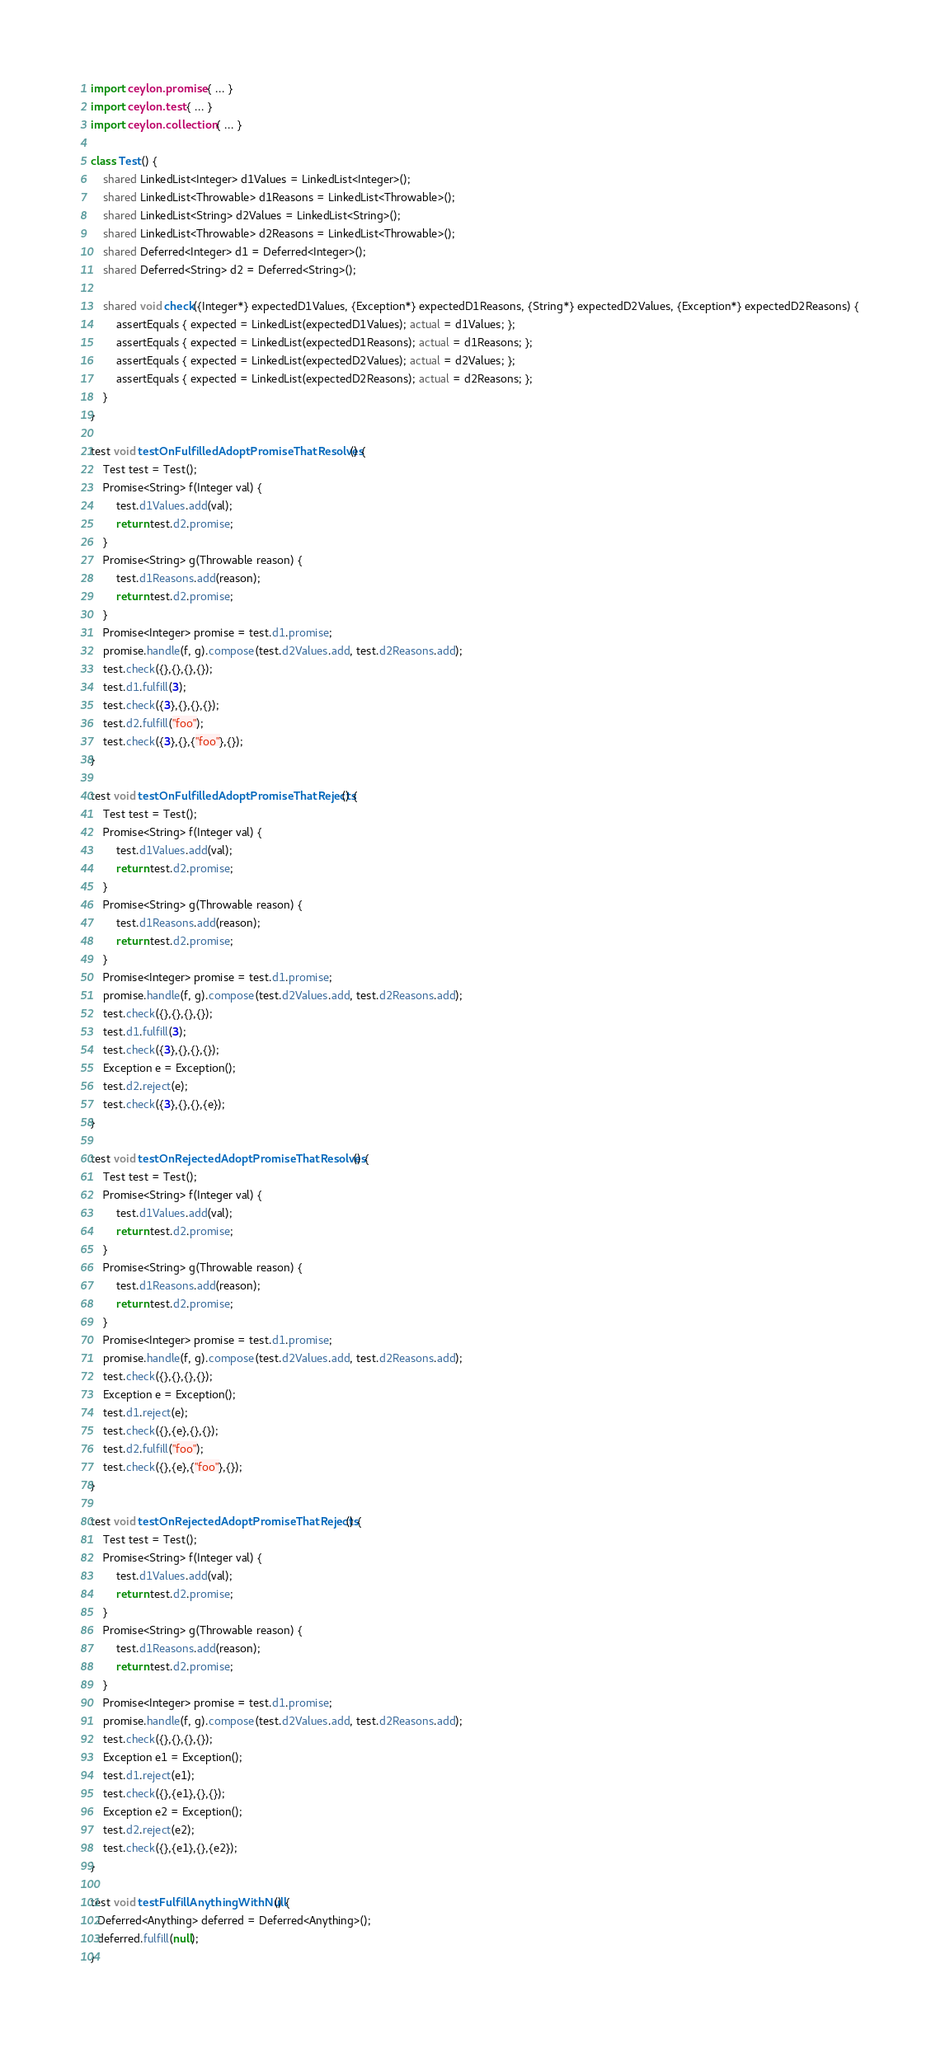Convert code to text. <code><loc_0><loc_0><loc_500><loc_500><_Ceylon_>import ceylon.promise { ... }
import ceylon.test { ... }
import ceylon.collection { ... }

class Test() {
    shared LinkedList<Integer> d1Values = LinkedList<Integer>();
    shared LinkedList<Throwable> d1Reasons = LinkedList<Throwable>();
    shared LinkedList<String> d2Values = LinkedList<String>();
    shared LinkedList<Throwable> d2Reasons = LinkedList<Throwable>();
    shared Deferred<Integer> d1 = Deferred<Integer>();
    shared Deferred<String> d2 = Deferred<String>();
    
    shared void check({Integer*} expectedD1Values, {Exception*} expectedD1Reasons, {String*} expectedD2Values, {Exception*} expectedD2Reasons) {
        assertEquals { expected = LinkedList(expectedD1Values); actual = d1Values; };
        assertEquals { expected = LinkedList(expectedD1Reasons); actual = d1Reasons; };
        assertEquals { expected = LinkedList(expectedD2Values); actual = d2Values; };
        assertEquals { expected = LinkedList(expectedD2Reasons); actual = d2Reasons; };
    }
}

test void testOnFulfilledAdoptPromiseThatResolves() {
    Test test = Test();
    Promise<String> f(Integer val) {
        test.d1Values.add(val);
        return test.d2.promise;
    }
    Promise<String> g(Throwable reason) {
        test.d1Reasons.add(reason);
        return test.d2.promise;
    }
    Promise<Integer> promise = test.d1.promise;
    promise.handle(f, g).compose(test.d2Values.add, test.d2Reasons.add);
    test.check({},{},{},{});
    test.d1.fulfill(3);
    test.check({3},{},{},{});
    test.d2.fulfill("foo");
    test.check({3},{},{"foo"},{});
}

test void testOnFulfilledAdoptPromiseThatRejects() {
    Test test = Test();
    Promise<String> f(Integer val) {
        test.d1Values.add(val);
        return test.d2.promise;
    }
    Promise<String> g(Throwable reason) {
        test.d1Reasons.add(reason);
        return test.d2.promise;
    }
    Promise<Integer> promise = test.d1.promise;
    promise.handle(f, g).compose(test.d2Values.add, test.d2Reasons.add);
    test.check({},{},{},{});
    test.d1.fulfill(3);
    test.check({3},{},{},{});
    Exception e = Exception();
    test.d2.reject(e);
    test.check({3},{},{},{e});
}

test void testOnRejectedAdoptPromiseThatResolves() {
    Test test = Test();
    Promise<String> f(Integer val) {
        test.d1Values.add(val);
        return test.d2.promise;
    }
    Promise<String> g(Throwable reason) {
        test.d1Reasons.add(reason);
        return test.d2.promise;
    }
    Promise<Integer> promise = test.d1.promise;
    promise.handle(f, g).compose(test.d2Values.add, test.d2Reasons.add);
    test.check({},{},{},{});
    Exception e = Exception();
    test.d1.reject(e);
    test.check({},{e},{},{});
    test.d2.fulfill("foo");
    test.check({},{e},{"foo"},{});
}

test void testOnRejectedAdoptPromiseThatRejects() {
    Test test = Test();
    Promise<String> f(Integer val) {
        test.d1Values.add(val);
        return test.d2.promise;
    }
    Promise<String> g(Throwable reason) {
        test.d1Reasons.add(reason);
        return test.d2.promise;
    }
    Promise<Integer> promise = test.d1.promise;
    promise.handle(f, g).compose(test.d2Values.add, test.d2Reasons.add);
    test.check({},{},{},{});
    Exception e1 = Exception();
    test.d1.reject(e1);
    test.check({},{e1},{},{});
    Exception e2 = Exception();
    test.d2.reject(e2);
    test.check({},{e1},{},{e2});
}

test void testFulfillAnythingWithNull() {
  Deferred<Anything> deferred = Deferred<Anything>();
  deferred.fulfill(null);
}
</code> 